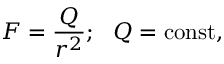<formula> <loc_0><loc_0><loc_500><loc_500>F = { \frac { Q } { r ^ { 2 } } } ; Q = c o n s t ,</formula> 